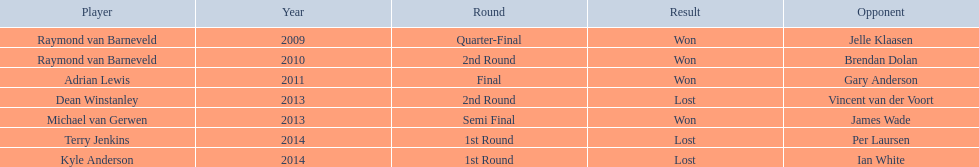What are the names of all the players involved? Raymond van Barneveld, Raymond van Barneveld, Adrian Lewis, Dean Winstanley, Michael van Gerwen, Terry Jenkins, Kyle Anderson. During which years was the championship offered? 2009, 2010, 2011, 2013, 2013, 2014, 2014. Out of these players, who took part in the 2011 event? Adrian Lewis. 